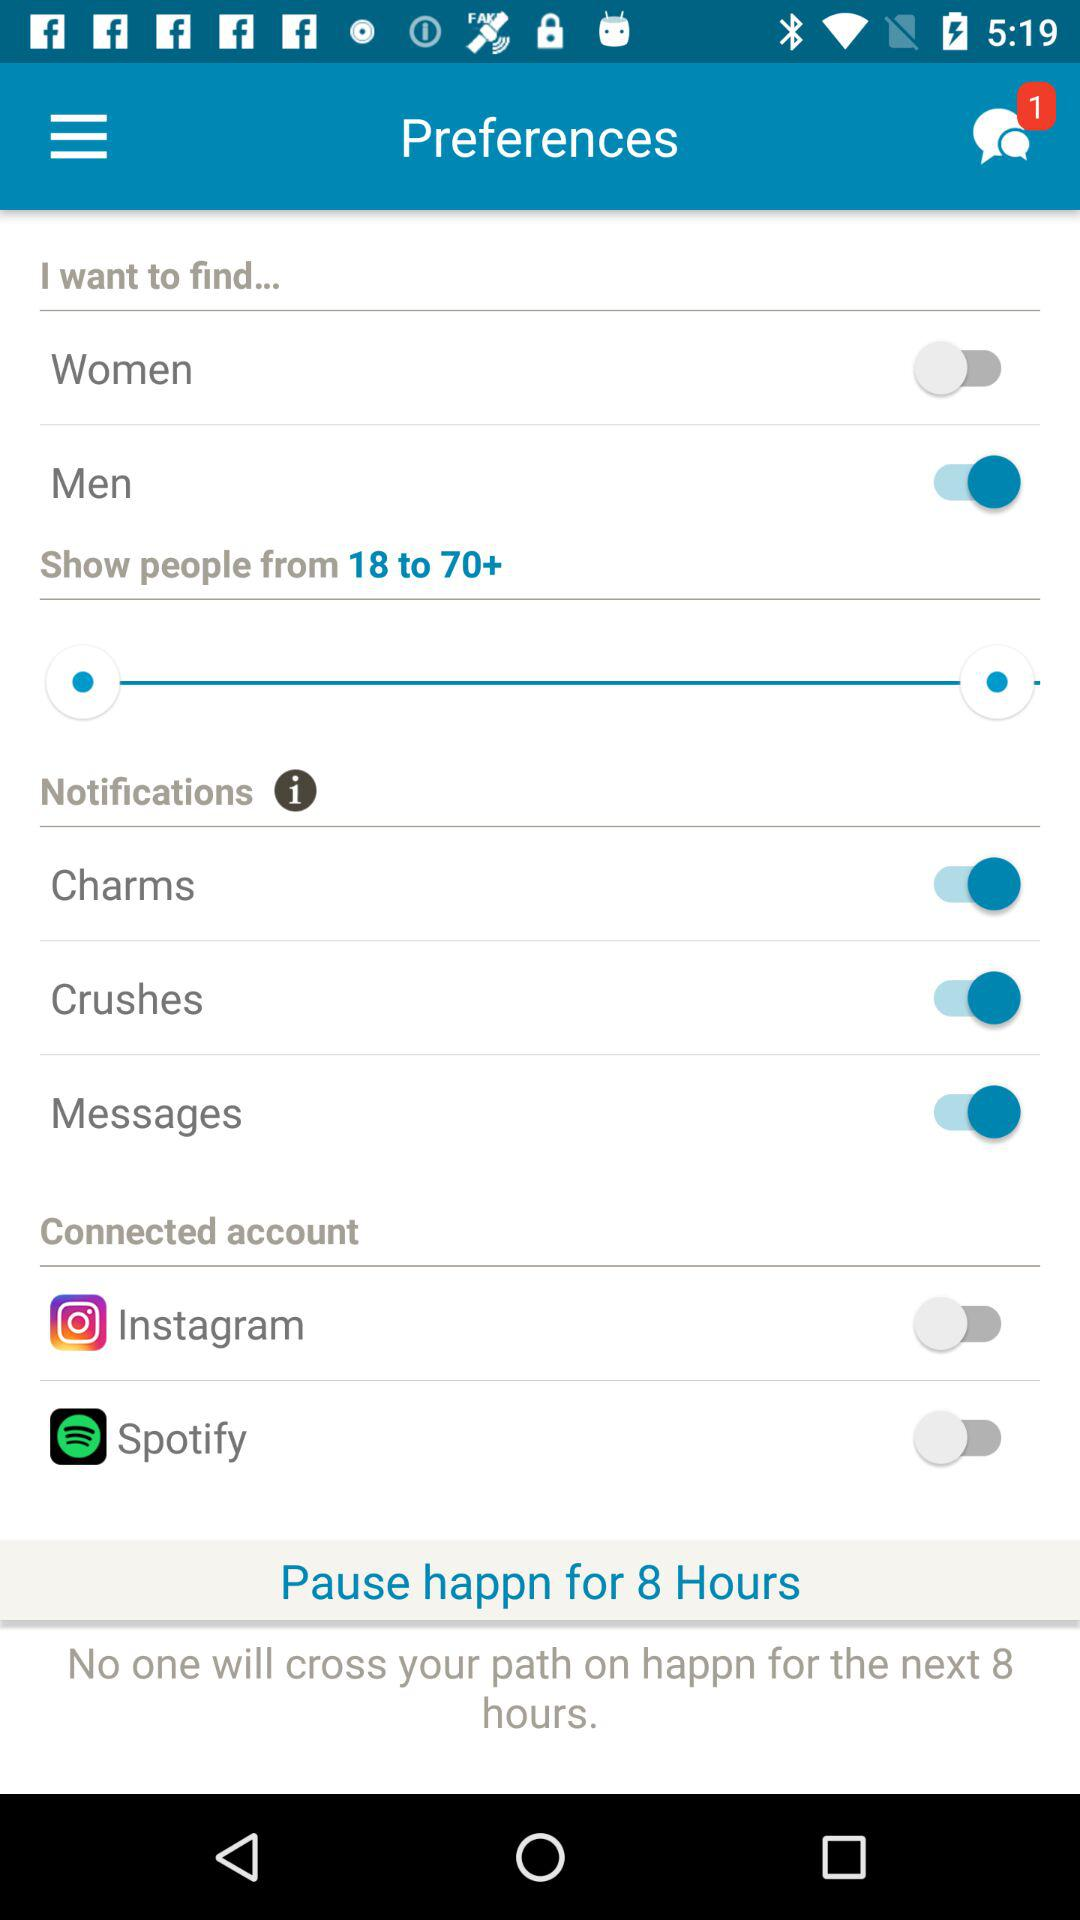How many unread messages are there? There is only 1 unread message. 